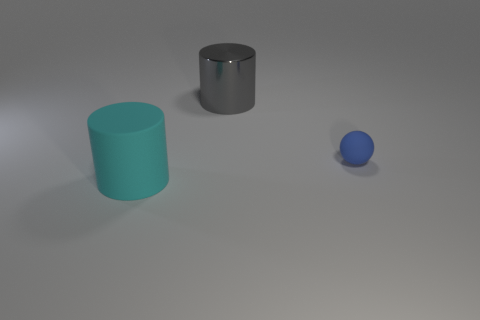Add 1 yellow rubber balls. How many objects exist? 4 Subtract all spheres. How many objects are left? 2 Subtract all gray cylinders. Subtract all blue cubes. How many cylinders are left? 1 Subtract all yellow cubes. How many red balls are left? 0 Subtract all purple rubber balls. Subtract all large rubber things. How many objects are left? 2 Add 1 gray metallic cylinders. How many gray metallic cylinders are left? 2 Add 2 red cubes. How many red cubes exist? 2 Subtract 0 brown cubes. How many objects are left? 3 